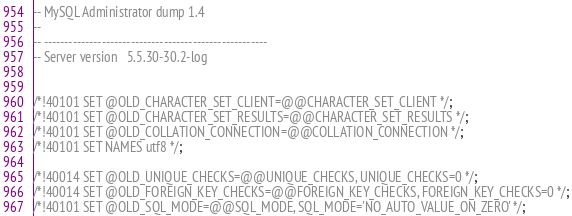Convert code to text. <code><loc_0><loc_0><loc_500><loc_500><_SQL_>-- MySQL Administrator dump 1.4
--
-- ------------------------------------------------------
-- Server version	5.5.30-30.2-log


/*!40101 SET @OLD_CHARACTER_SET_CLIENT=@@CHARACTER_SET_CLIENT */;
/*!40101 SET @OLD_CHARACTER_SET_RESULTS=@@CHARACTER_SET_RESULTS */;
/*!40101 SET @OLD_COLLATION_CONNECTION=@@COLLATION_CONNECTION */;
/*!40101 SET NAMES utf8 */;

/*!40014 SET @OLD_UNIQUE_CHECKS=@@UNIQUE_CHECKS, UNIQUE_CHECKS=0 */;
/*!40014 SET @OLD_FOREIGN_KEY_CHECKS=@@FOREIGN_KEY_CHECKS, FOREIGN_KEY_CHECKS=0 */;
/*!40101 SET @OLD_SQL_MODE=@@SQL_MODE, SQL_MODE='NO_AUTO_VALUE_ON_ZERO' */;


</code> 